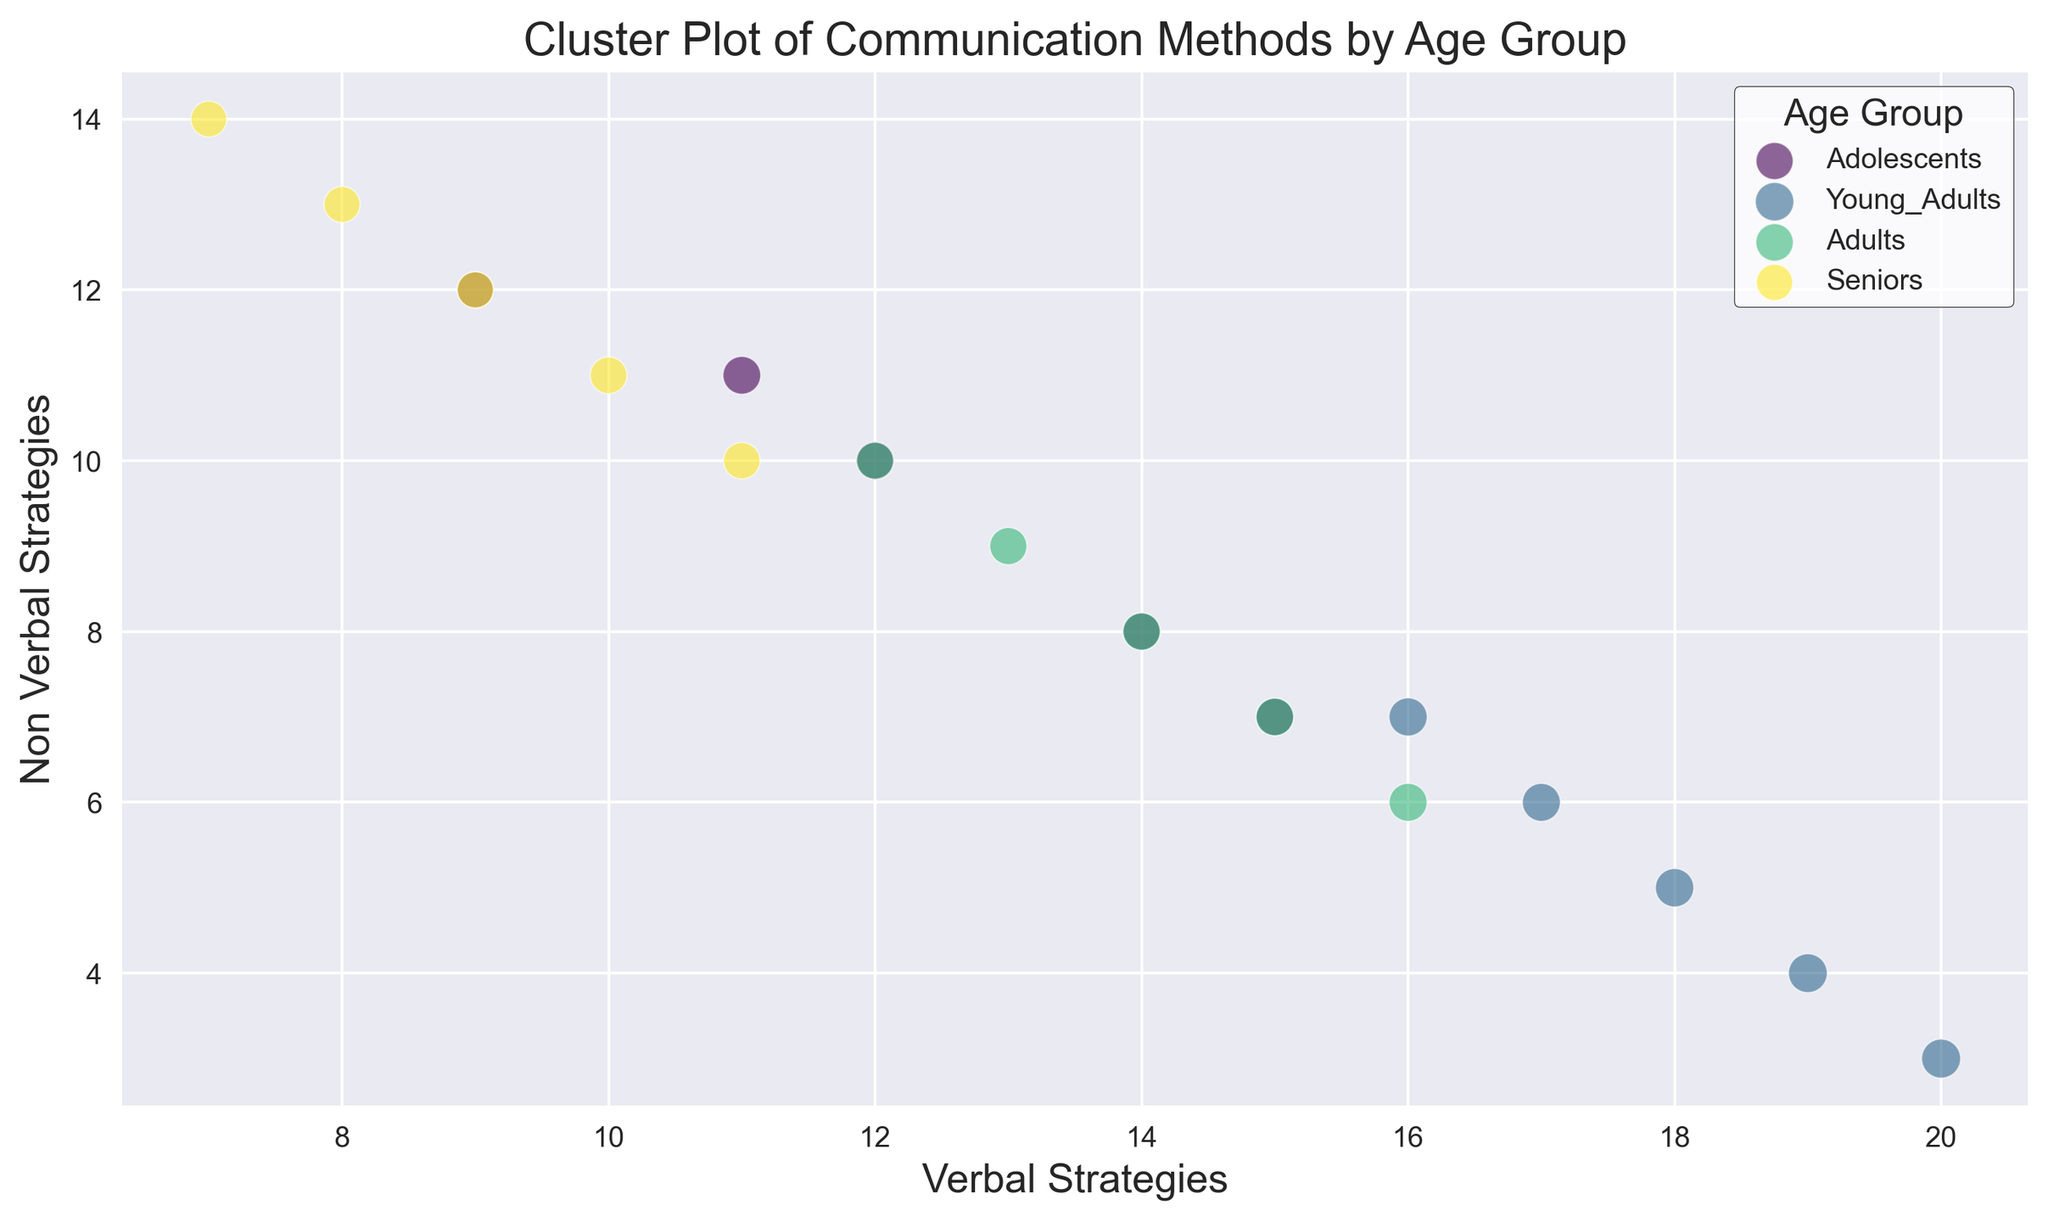How many age groups are represented in the plot? There are four distinct colors in the plot, each representing a different age group. The legend indicates the labels for these age groups: Adolescents, Young Adults, Adults, and Seniors.
Answer: 4 Which age group shows the highest perceived effectiveness overall? By observing the sizes of the bubbles, Young Adults have the largest-sized bubbles, indicating the highest perceived effectiveness on average.
Answer: Young Adults Is there a distinct clustering pattern observed between verbal and non-verbal strategies for Seniors? Seniors have more Non Verbal Strategies than Verbal Strategies, forming a visible cluster in the top left of the plot.
Answer: Yes Compare the perceived effectiveness of the most verbal strategy for Adolescents and Young Adults. Which is greater? Adolescents' most verbal strategy point (15 Verbal Strategies) has a perceived effectiveness of 0.85, while Young Adults' most verbal strategy point (20 Verbal Strategies) has a perceived effectiveness of 0.93, indicating Young Adults have higher perceived effectiveness.
Answer: Young Adults What is the relationship between verbal strategies and perceived effectiveness among Adults? More verbal strategies seem to correspond to higher perceived effectiveness among Adults. This can be seen with higher densities of verbal strategies leading to larger bubble sizes.
Answer: Positive correlation Which age group utilizes more non-verbal strategies with medium effectiveness (around 0.80-0.85)? Seniors frequently use non-verbal strategies with medium effectiveness, as most of the bubbles with 10 or more non-verbal strategies lie within the 0.80-0.85 perceived effectiveness range.
Answer: Seniors What is the average non-verbal strategy used by Young Adults? Young Adults have non-verbal strategies ranging from 3 to 7. The average can be calculated as (3+4+5+6+7)/5 = 25/5 = 5.
Answer: 5 Which age group has the most balanced use of verbal and non-verbal strategies, and how can you tell? Adolescents show a more balanced use of verbal and non-verbal strategies, as the points are more evenly distributed around the diagonal line from (0,0) to (20, 20).
Answer: Adolescents Is there any age group that shows a significantly different pattern from the others? Yes, Seniors show a distinct pattern with higher usage of non-verbal strategies compared to verbal ones, creating an outlier clustering pattern.
Answer: Yes 